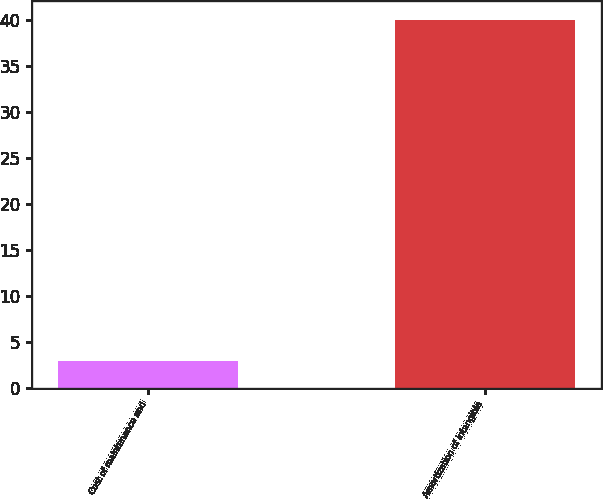Convert chart to OTSL. <chart><loc_0><loc_0><loc_500><loc_500><bar_chart><fcel>Cost of maintenance and<fcel>Amortization of intangible<nl><fcel>3<fcel>40<nl></chart> 